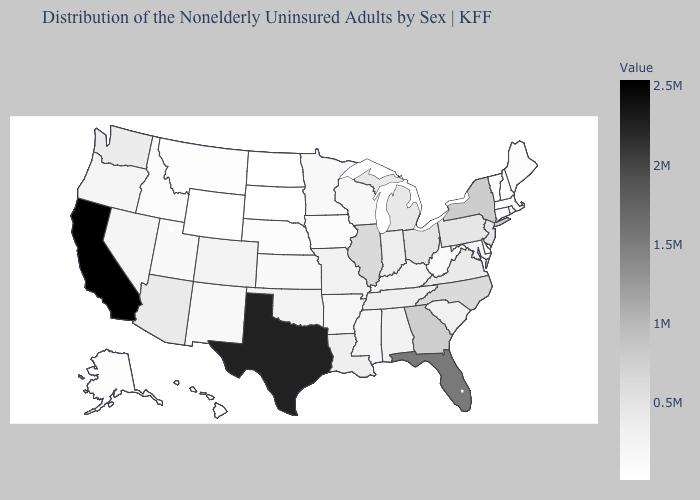Does Illinois have a lower value than Texas?
Be succinct. Yes. Among the states that border Indiana , which have the lowest value?
Write a very short answer. Kentucky. Does Iowa have a higher value than Illinois?
Be succinct. No. Does the map have missing data?
Give a very brief answer. No. Does Vermont have the lowest value in the USA?
Be succinct. Yes. Is the legend a continuous bar?
Answer briefly. Yes. Does Washington have a higher value than Texas?
Answer briefly. No. 